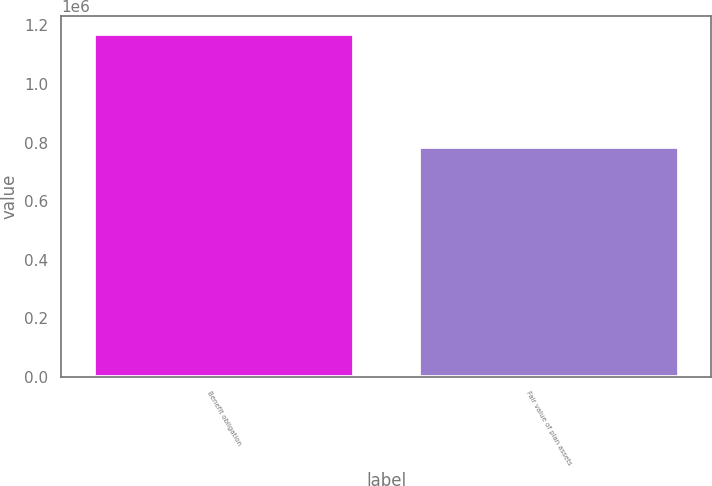<chart> <loc_0><loc_0><loc_500><loc_500><bar_chart><fcel>Benefit obligation<fcel>Fair value of plan assets<nl><fcel>1.17227e+06<fcel>784681<nl></chart> 